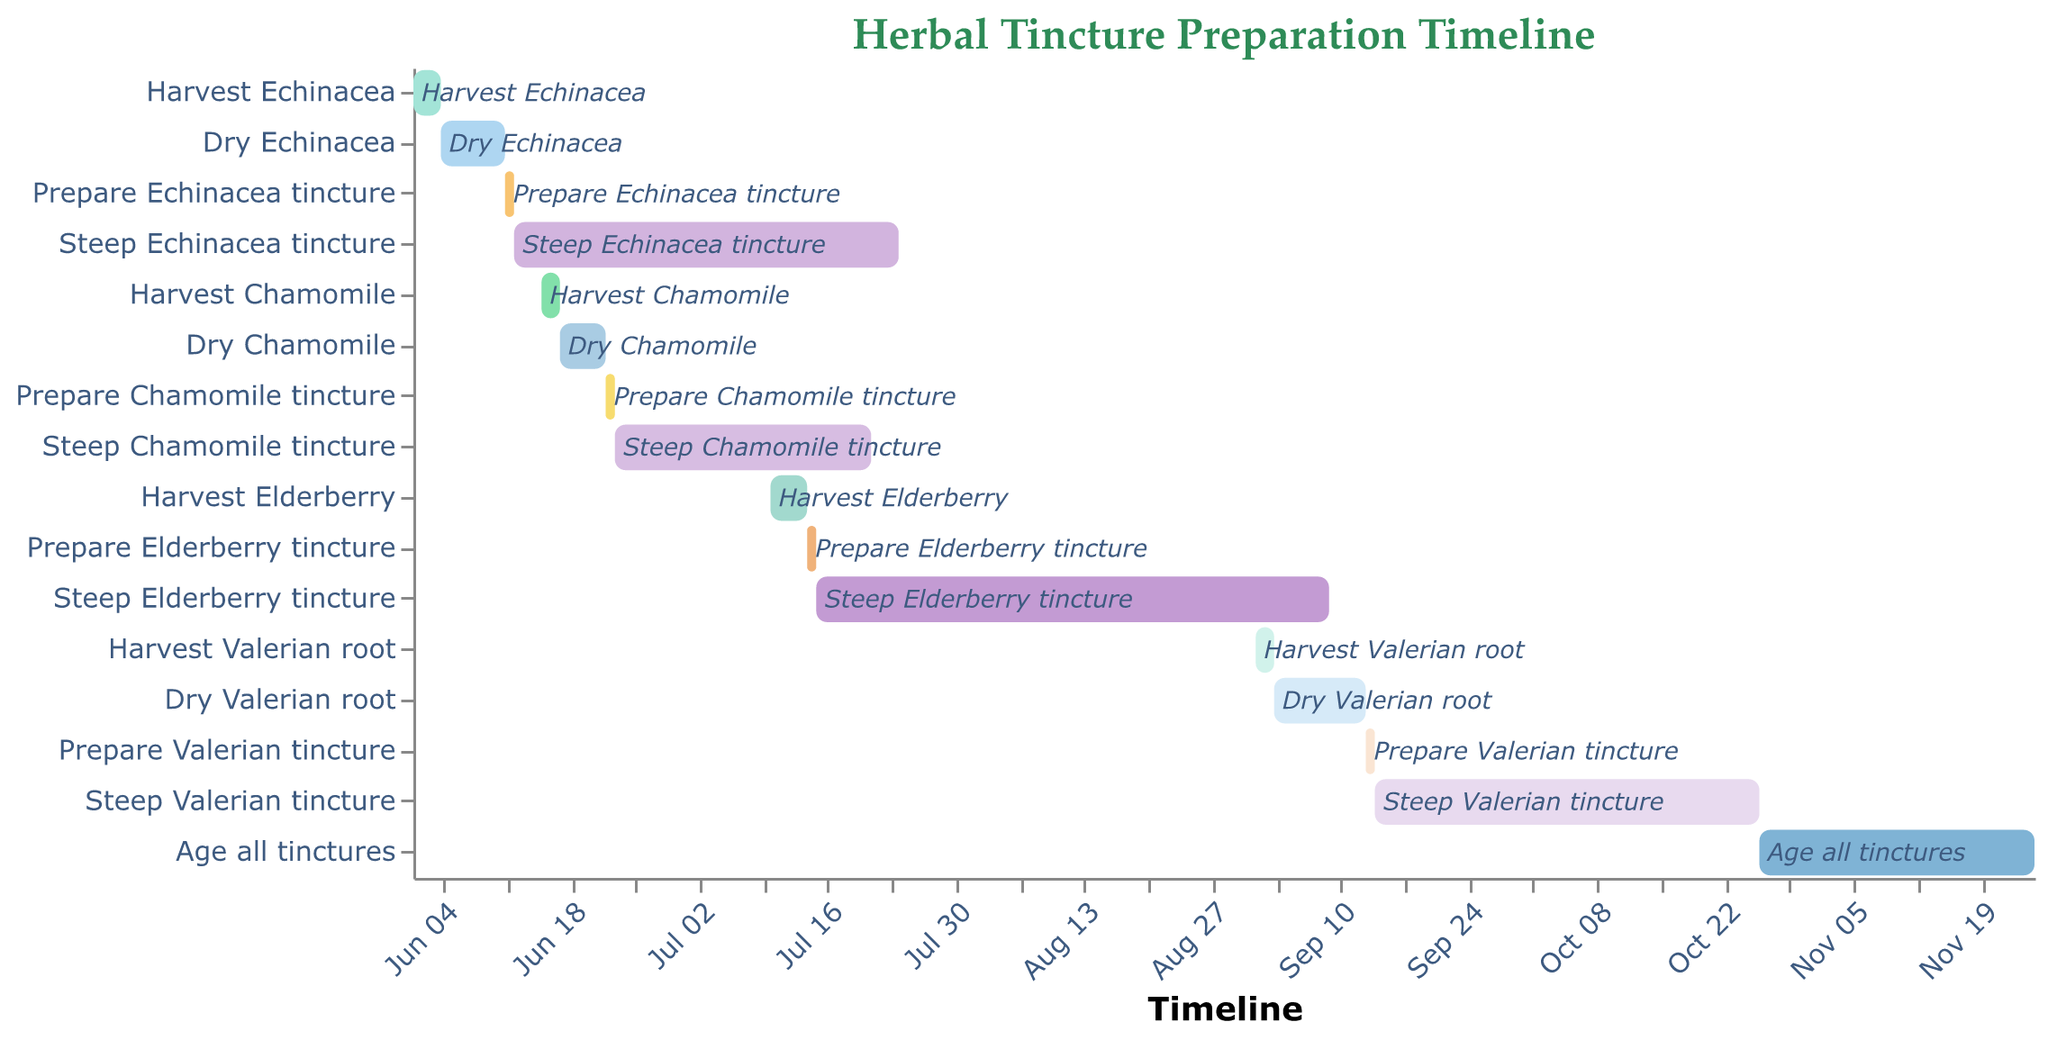What's the title of the Gantt Chart? The title of the Gantt Chart is displayed at the top and reads "Herbal Tincture Preparation Timeline".
Answer: Herbal Tincture Preparation Timeline When does the preparation of the Echinacea tincture start? By looking at the start date of the "Prepare Echinacea tincture" task, we can see that it starts on 2023-06-11.
Answer: 2023-06-11 What is the duration of the "Steep Valerian tincture" period? The duration of the "Steep Valerian tincture" task is provided as 42 days.
Answer: 42 days Which task has the longest duration? By comparing the durations of all tasks, the "Steep Elderberry tincture" task has the longest duration of 56 days.
Answer: Steep Elderberry tincture How many days does it take from harvesting to steeping the Echinacea tincture? The sequence includes harvesting (3 days), drying (7 days), and preparing (1 day). Adding these up: 3 + 7 + 1 = 11 days.
Answer: 11 days Which tincture starts its steeping process the earliest? The tincture with the earliest steeping start date is the "Steep Echinacea tincture" which starts on 2023-06-12.
Answer: Echinacea tincture When does the aging process for all tinctures start and how long does it last? The "Age all tinctures" task starts on 2023-10-26 and lasts for 30 days.
Answer: 2023-10-26, 30 days How does the duration of steeping Chamomile tincture compare to Echinacea tincture? The "Steep Chamomile tincture" duration is 28 days, while the "Steep Echinacea tincture" duration is 42 days. Comparing them, Chamomile steeping is 14 days shorter.
Answer: 14 days shorter 